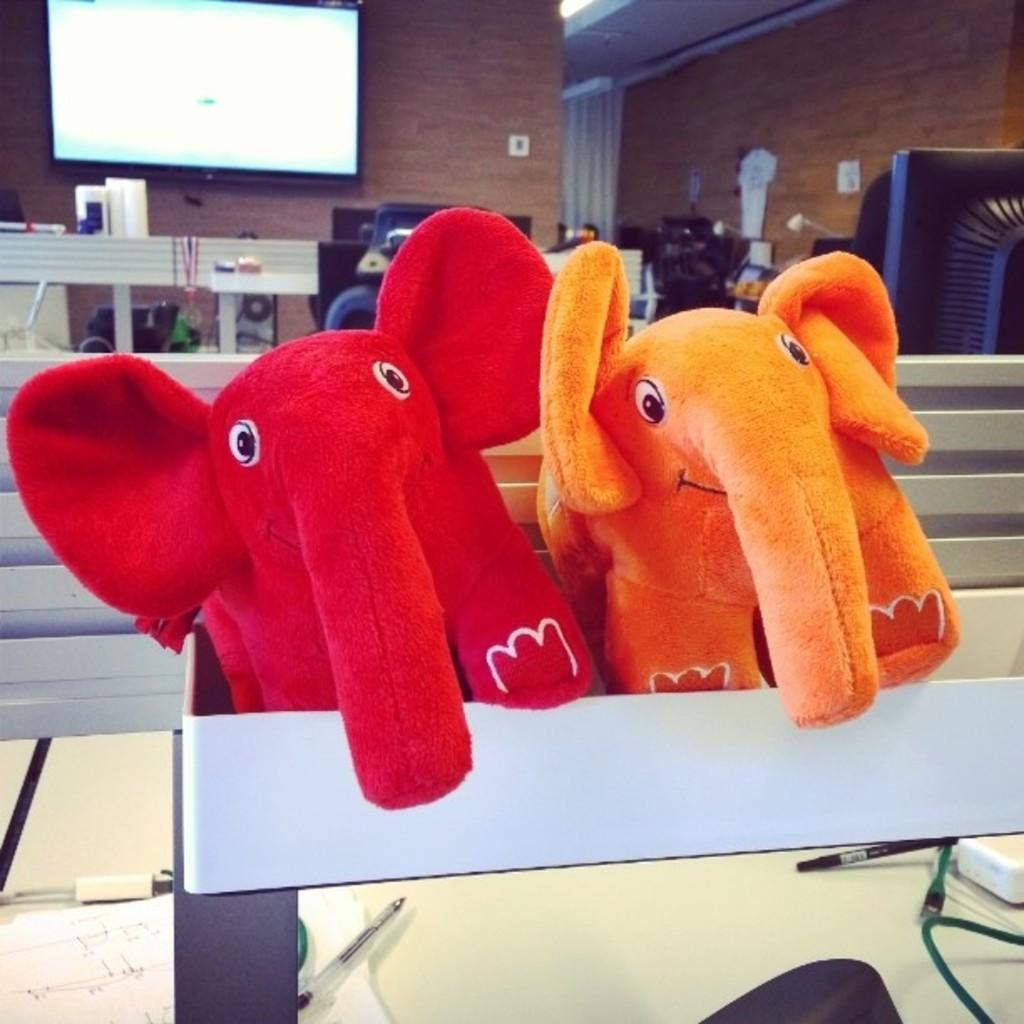What type of toys are present in the image? There are elephant toys in the image. What can be seen in the background of the image? There is a wall in the image. What type of furniture is present in the image? There are benches and chairs in the image. What is the purpose of the screen in the image? The purpose of the screen in the image is not specified, but it could be used for displaying information or images. How many oranges are on the benches in the image? There are no oranges present in the image. 